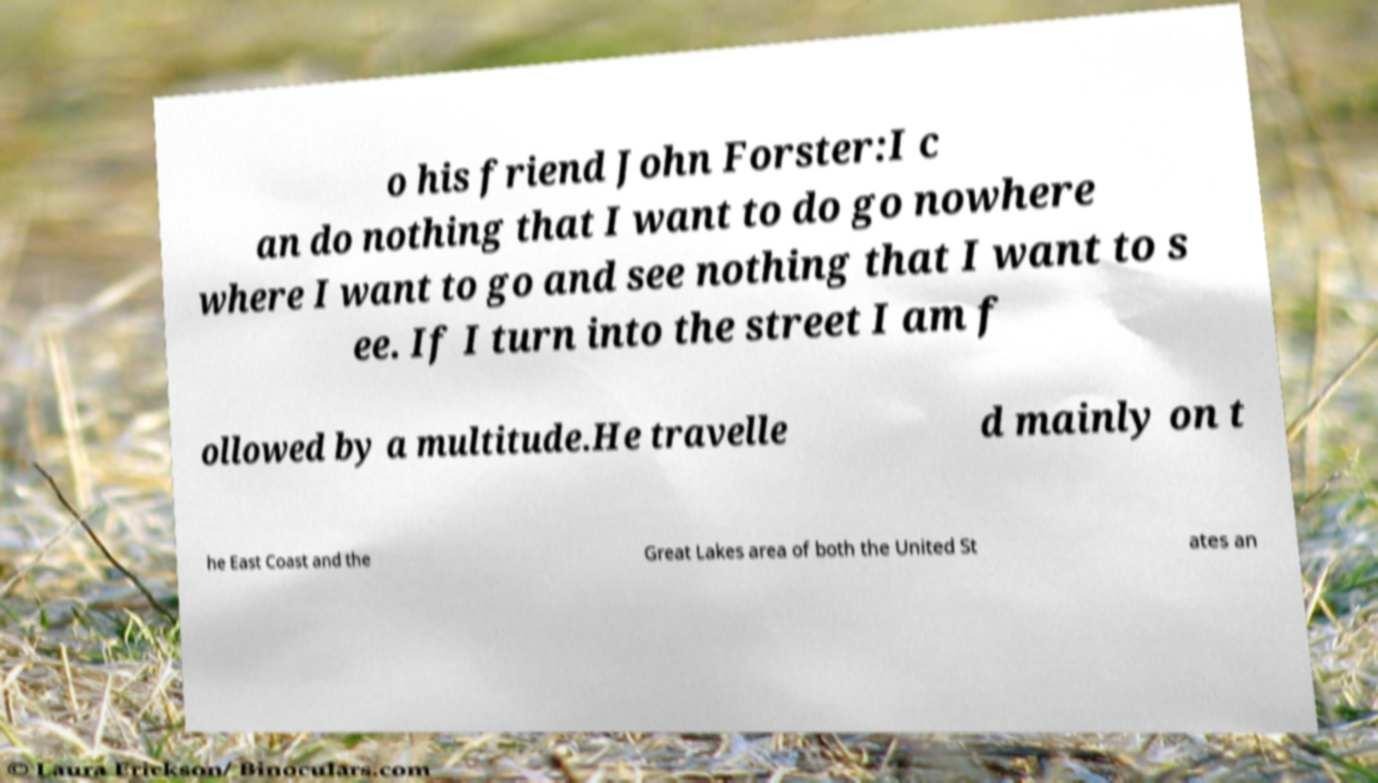Please read and relay the text visible in this image. What does it say? o his friend John Forster:I c an do nothing that I want to do go nowhere where I want to go and see nothing that I want to s ee. If I turn into the street I am f ollowed by a multitude.He travelle d mainly on t he East Coast and the Great Lakes area of both the United St ates an 